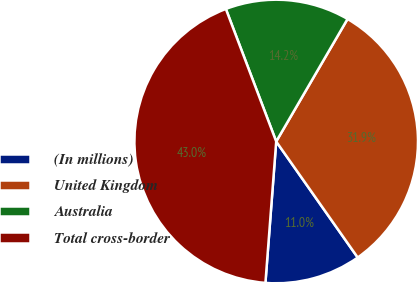Convert chart. <chart><loc_0><loc_0><loc_500><loc_500><pie_chart><fcel>(In millions)<fcel>United Kingdom<fcel>Australia<fcel>Total cross-border<nl><fcel>10.96%<fcel>31.86%<fcel>14.17%<fcel>43.01%<nl></chart> 